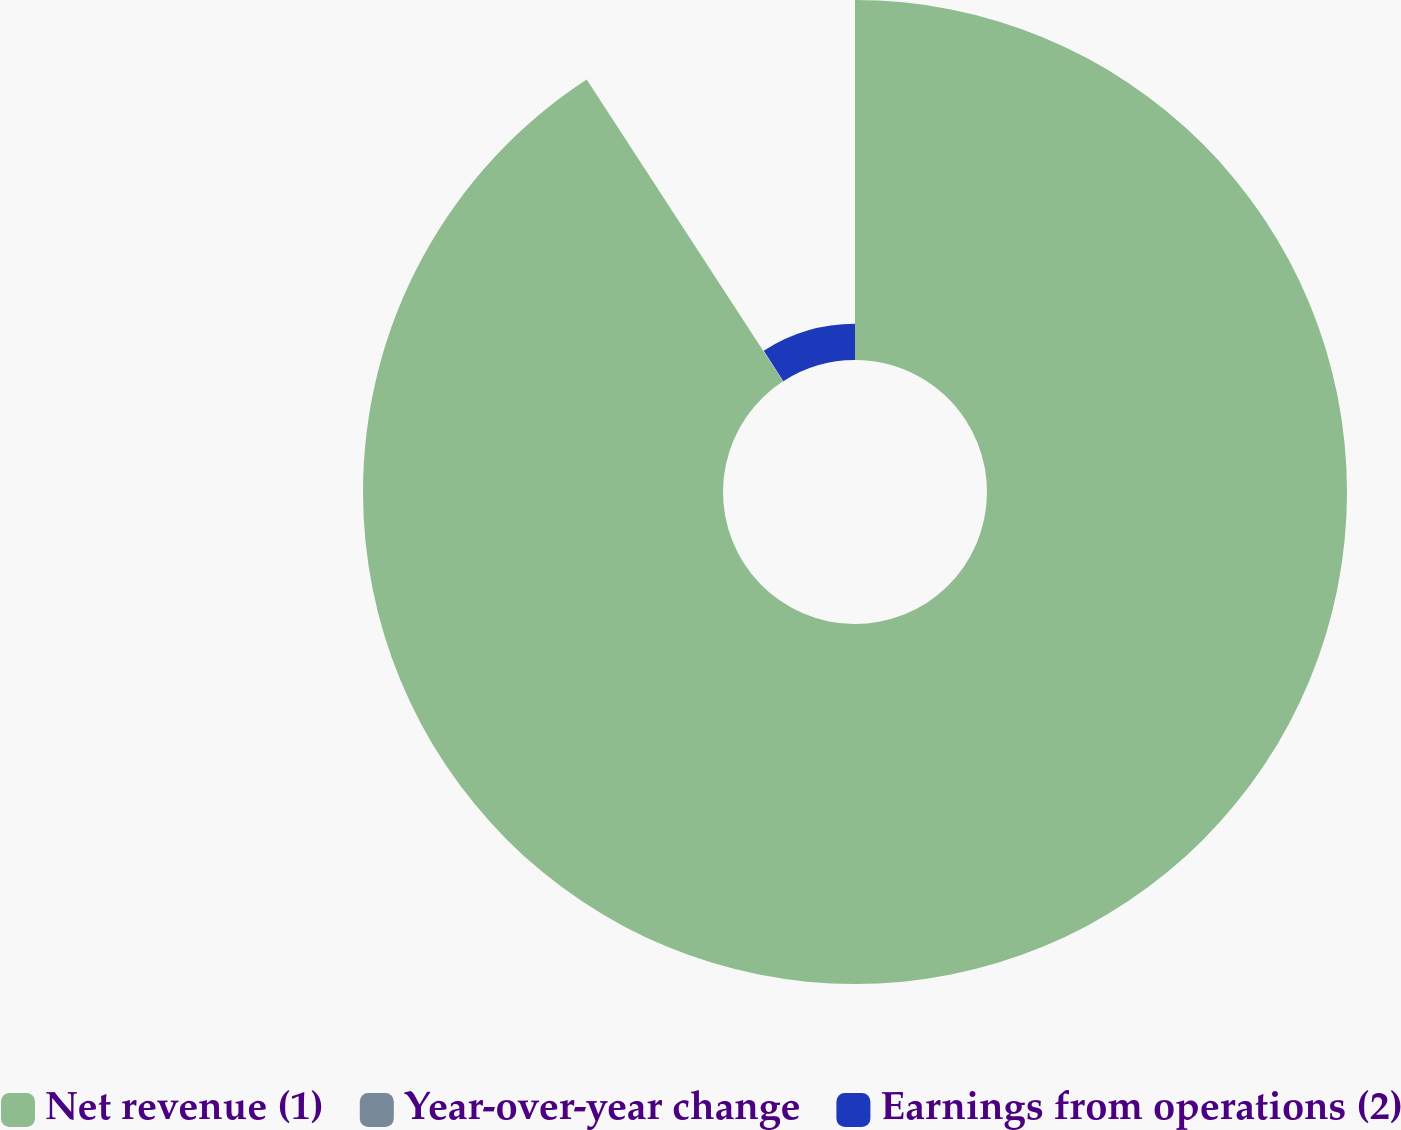Convert chart. <chart><loc_0><loc_0><loc_500><loc_500><pie_chart><fcel>Net revenue (1)<fcel>Year-over-year change<fcel>Earnings from operations (2)<nl><fcel>90.82%<fcel>0.05%<fcel>9.13%<nl></chart> 